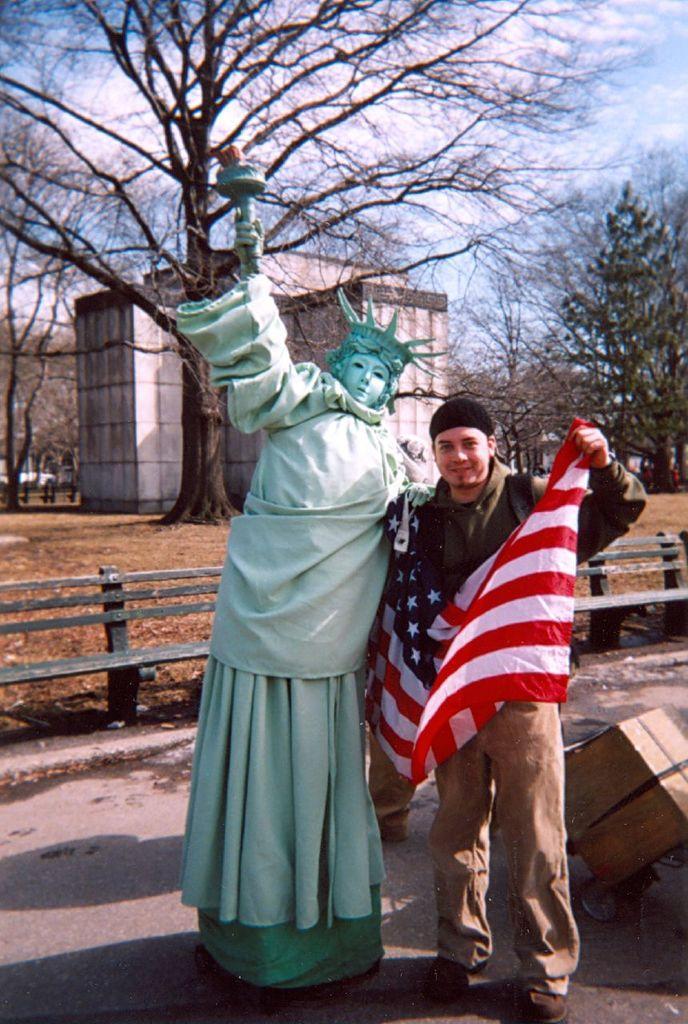Describe this image in one or two sentences. In this picture we can see a man, he is holding a flag, beside him we can see a statue, in the background we can see few trees, a building and clouds. 